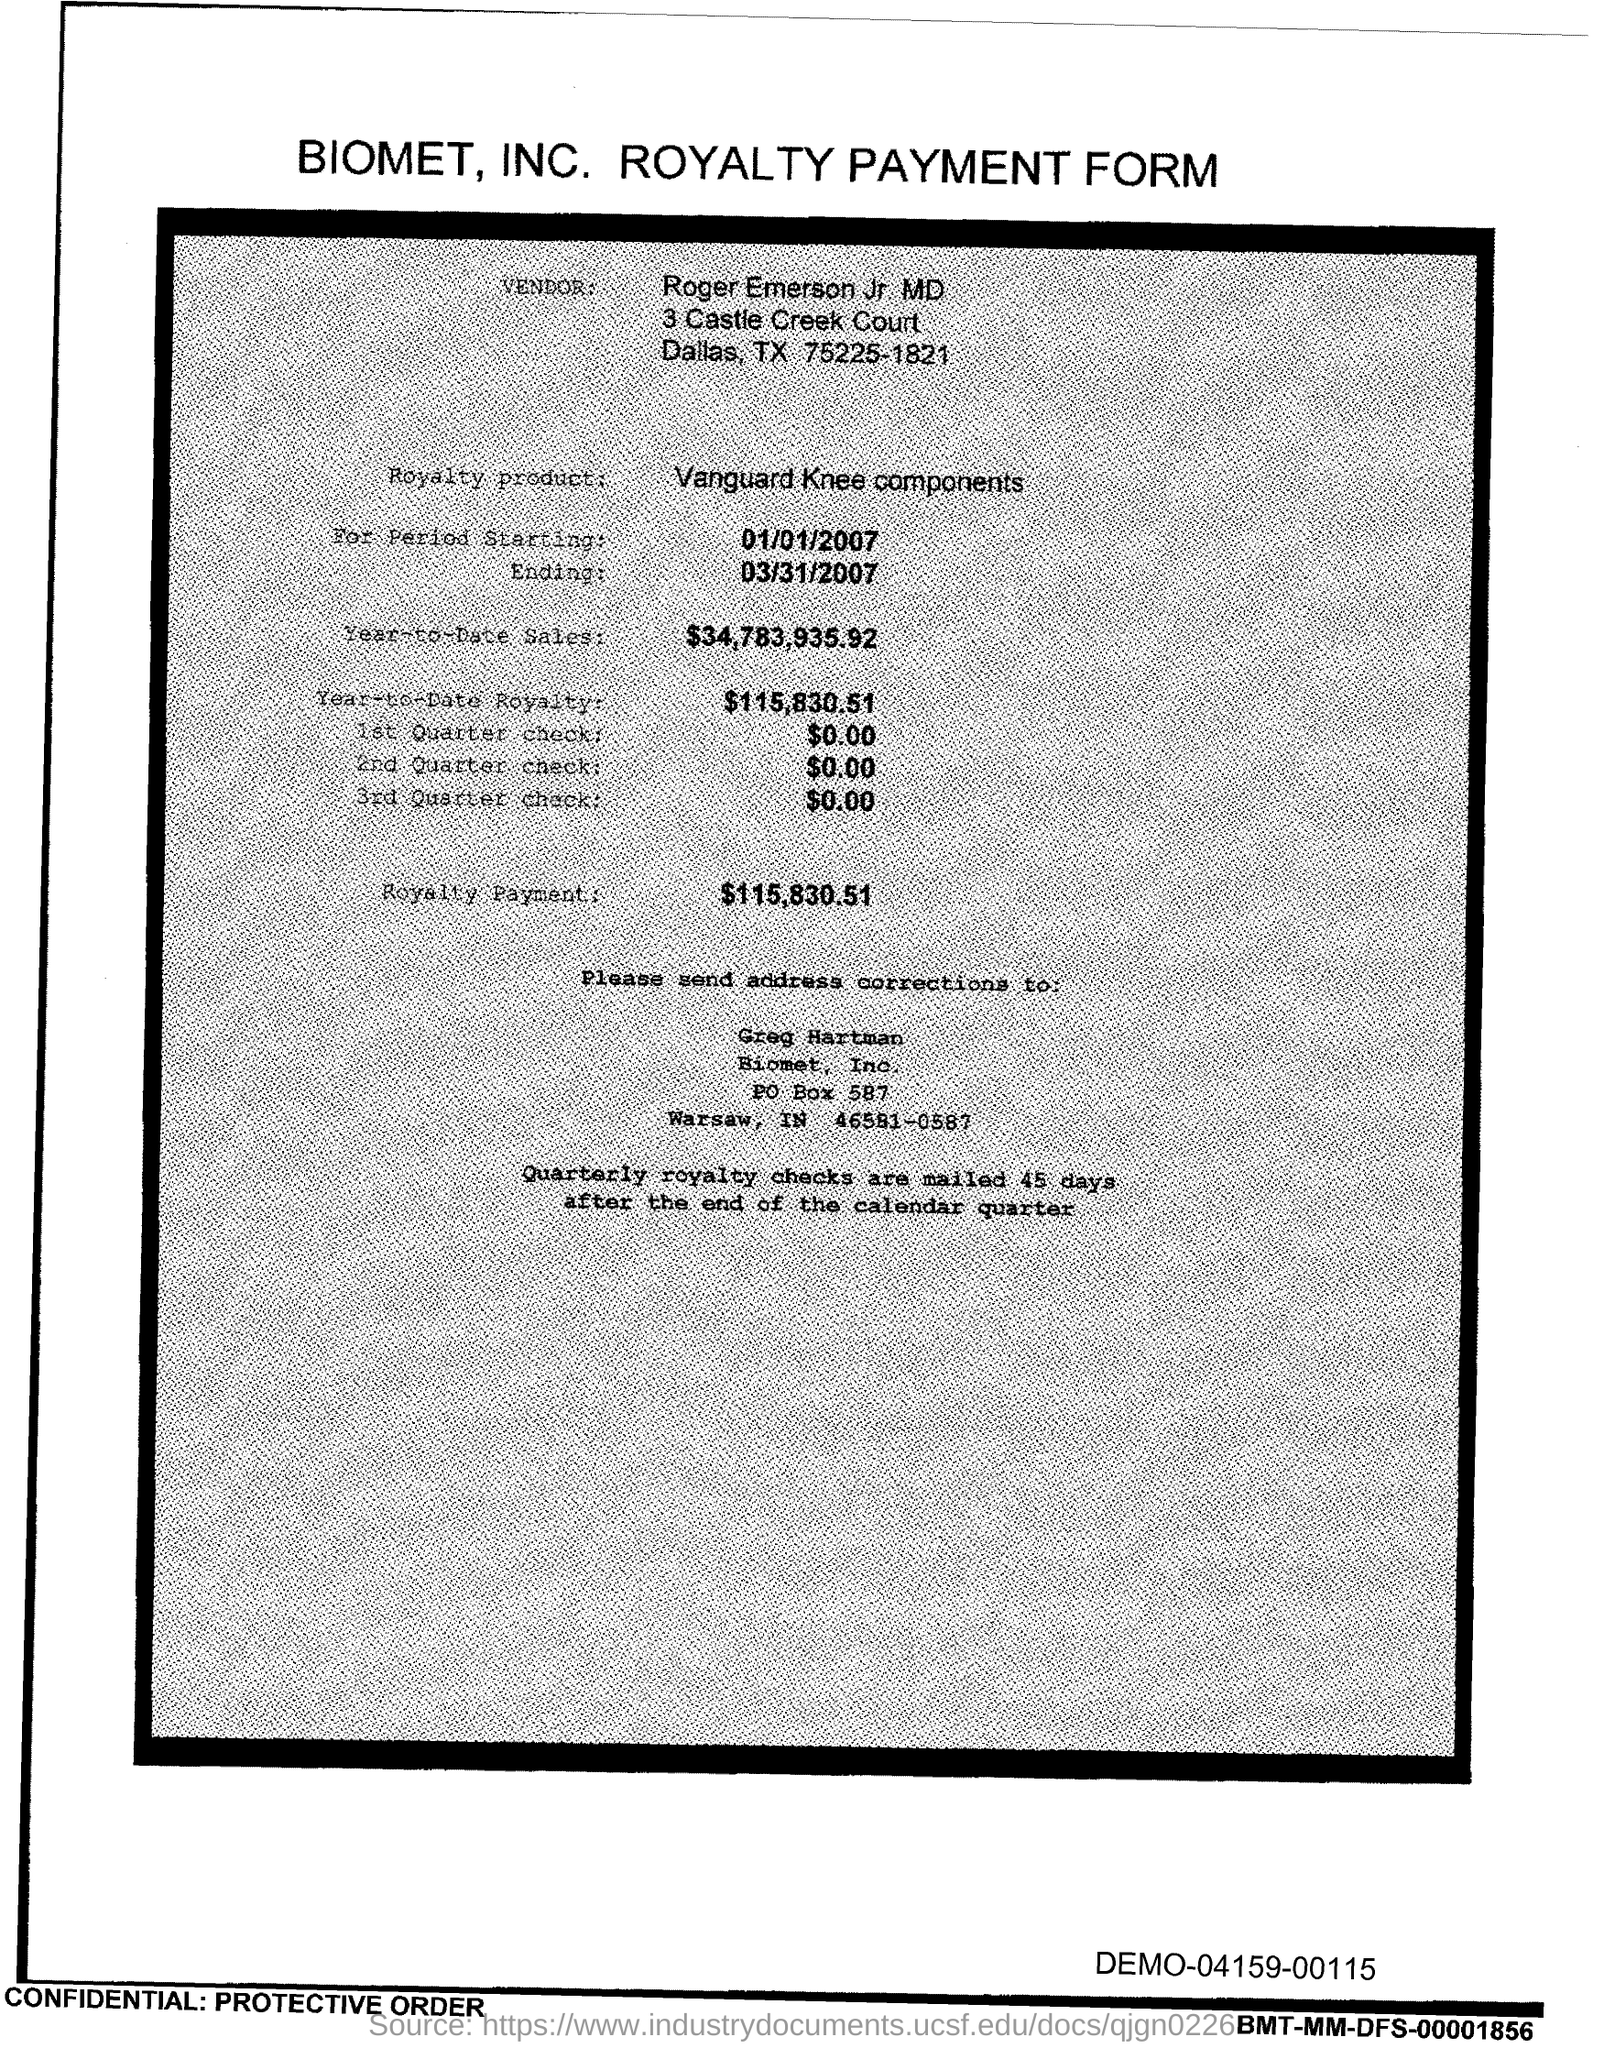Point out several critical features in this image. The royalty payment for the product mentioned in the form is $115,830.51. The royalty product, in the form of Vanguard Knee Components, is [what]. The amount mentioned in the 2nd Quarter check form is $0.00. Roger Emerson Jr. MD is the vendor name provided in the form. The year-to-date royalty for the product is $115,830.51. 